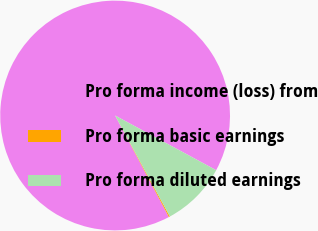<chart> <loc_0><loc_0><loc_500><loc_500><pie_chart><fcel>Pro forma income (loss) from<fcel>Pro forma basic earnings<fcel>Pro forma diluted earnings<nl><fcel>90.65%<fcel>0.15%<fcel>9.2%<nl></chart> 